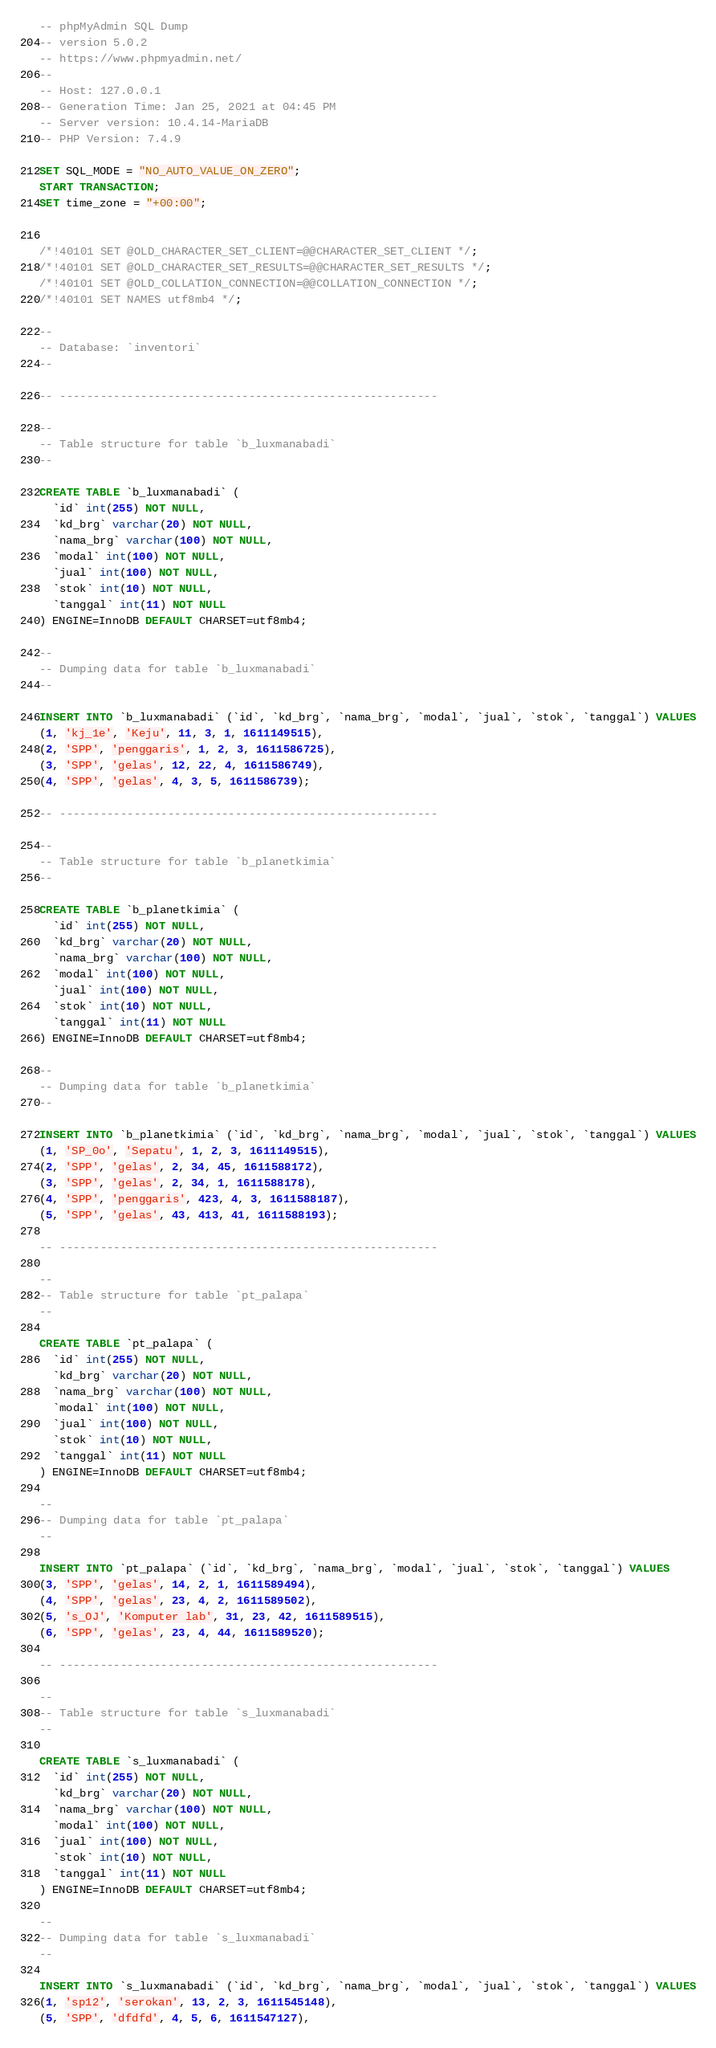Convert code to text. <code><loc_0><loc_0><loc_500><loc_500><_SQL_>-- phpMyAdmin SQL Dump
-- version 5.0.2
-- https://www.phpmyadmin.net/
--
-- Host: 127.0.0.1
-- Generation Time: Jan 25, 2021 at 04:45 PM
-- Server version: 10.4.14-MariaDB
-- PHP Version: 7.4.9

SET SQL_MODE = "NO_AUTO_VALUE_ON_ZERO";
START TRANSACTION;
SET time_zone = "+00:00";


/*!40101 SET @OLD_CHARACTER_SET_CLIENT=@@CHARACTER_SET_CLIENT */;
/*!40101 SET @OLD_CHARACTER_SET_RESULTS=@@CHARACTER_SET_RESULTS */;
/*!40101 SET @OLD_COLLATION_CONNECTION=@@COLLATION_CONNECTION */;
/*!40101 SET NAMES utf8mb4 */;

--
-- Database: `inventori`
--

-- --------------------------------------------------------

--
-- Table structure for table `b_luxmanabadi`
--

CREATE TABLE `b_luxmanabadi` (
  `id` int(255) NOT NULL,
  `kd_brg` varchar(20) NOT NULL,
  `nama_brg` varchar(100) NOT NULL,
  `modal` int(100) NOT NULL,
  `jual` int(100) NOT NULL,
  `stok` int(10) NOT NULL,
  `tanggal` int(11) NOT NULL
) ENGINE=InnoDB DEFAULT CHARSET=utf8mb4;

--
-- Dumping data for table `b_luxmanabadi`
--

INSERT INTO `b_luxmanabadi` (`id`, `kd_brg`, `nama_brg`, `modal`, `jual`, `stok`, `tanggal`) VALUES
(1, 'kj_1e', 'Keju', 11, 3, 1, 1611149515),
(2, 'SPP', 'penggaris', 1, 2, 3, 1611586725),
(3, 'SPP', 'gelas', 12, 22, 4, 1611586749),
(4, 'SPP', 'gelas', 4, 3, 5, 1611586739);

-- --------------------------------------------------------

--
-- Table structure for table `b_planetkimia`
--

CREATE TABLE `b_planetkimia` (
  `id` int(255) NOT NULL,
  `kd_brg` varchar(20) NOT NULL,
  `nama_brg` varchar(100) NOT NULL,
  `modal` int(100) NOT NULL,
  `jual` int(100) NOT NULL,
  `stok` int(10) NOT NULL,
  `tanggal` int(11) NOT NULL
) ENGINE=InnoDB DEFAULT CHARSET=utf8mb4;

--
-- Dumping data for table `b_planetkimia`
--

INSERT INTO `b_planetkimia` (`id`, `kd_brg`, `nama_brg`, `modal`, `jual`, `stok`, `tanggal`) VALUES
(1, 'SP_0o', 'Sepatu', 1, 2, 3, 1611149515),
(2, 'SPP', 'gelas', 2, 34, 45, 1611588172),
(3, 'SPP', 'gelas', 2, 34, 1, 1611588178),
(4, 'SPP', 'penggaris', 423, 4, 3, 1611588187),
(5, 'SPP', 'gelas', 43, 413, 41, 1611588193);

-- --------------------------------------------------------

--
-- Table structure for table `pt_palapa`
--

CREATE TABLE `pt_palapa` (
  `id` int(255) NOT NULL,
  `kd_brg` varchar(20) NOT NULL,
  `nama_brg` varchar(100) NOT NULL,
  `modal` int(100) NOT NULL,
  `jual` int(100) NOT NULL,
  `stok` int(10) NOT NULL,
  `tanggal` int(11) NOT NULL
) ENGINE=InnoDB DEFAULT CHARSET=utf8mb4;

--
-- Dumping data for table `pt_palapa`
--

INSERT INTO `pt_palapa` (`id`, `kd_brg`, `nama_brg`, `modal`, `jual`, `stok`, `tanggal`) VALUES
(3, 'SPP', 'gelas', 14, 2, 1, 1611589494),
(4, 'SPP', 'gelas', 23, 4, 2, 1611589502),
(5, 's_OJ', 'Komputer lab', 31, 23, 42, 1611589515),
(6, 'SPP', 'gelas', 23, 4, 44, 1611589520);

-- --------------------------------------------------------

--
-- Table structure for table `s_luxmanabadi`
--

CREATE TABLE `s_luxmanabadi` (
  `id` int(255) NOT NULL,
  `kd_brg` varchar(20) NOT NULL,
  `nama_brg` varchar(100) NOT NULL,
  `modal` int(100) NOT NULL,
  `jual` int(100) NOT NULL,
  `stok` int(10) NOT NULL,
  `tanggal` int(11) NOT NULL
) ENGINE=InnoDB DEFAULT CHARSET=utf8mb4;

--
-- Dumping data for table `s_luxmanabadi`
--

INSERT INTO `s_luxmanabadi` (`id`, `kd_brg`, `nama_brg`, `modal`, `jual`, `stok`, `tanggal`) VALUES
(1, 'sp12', 'serokan', 13, 2, 3, 1611545148),
(5, 'SPP', 'dfdfd', 4, 5, 6, 1611547127),</code> 